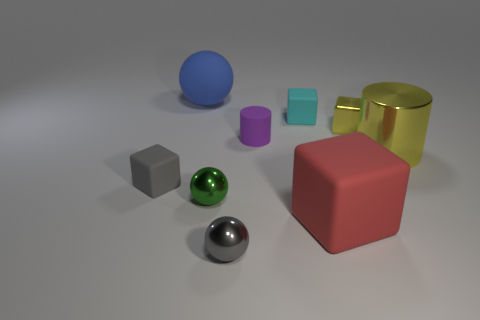Subtract all cubes. How many objects are left? 5 Subtract 0 red cylinders. How many objects are left? 9 Subtract all small purple metal objects. Subtract all tiny green shiny objects. How many objects are left? 8 Add 1 small metal balls. How many small metal balls are left? 3 Add 2 purple cylinders. How many purple cylinders exist? 3 